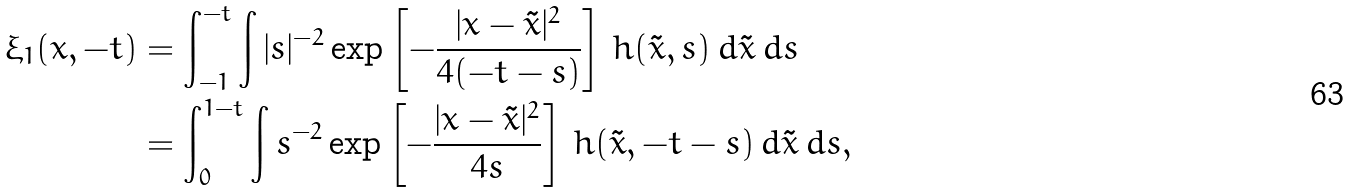<formula> <loc_0><loc_0><loc_500><loc_500>\xi _ { 1 } ( x , - t ) & = \int _ { - 1 } ^ { - t } \int | s | ^ { - 2 } \exp \left [ - \frac { | x - \tilde { x } | ^ { 2 } } { 4 ( - t - s ) } \right ] \, h ( \tilde { x } , s ) \, d \tilde { x } \, d s \\ & = \int ^ { 1 - t } _ { 0 } \int s ^ { - 2 } \exp \left [ - \frac { | x - \tilde { x } | ^ { 2 } } { 4 s } \right ] \, h ( \tilde { x } , - t - s ) \, d \tilde { x } \, d s ,</formula> 